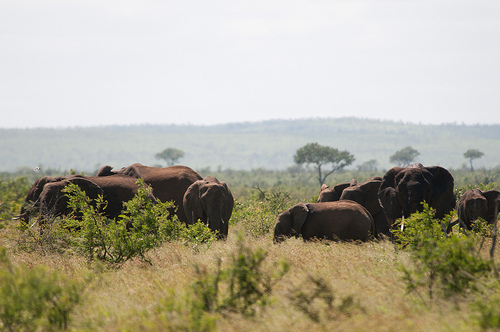Please provide a short description for this region: [0.45, 0.4, 0.56, 0.47]. This region depicts a distant mountain amidst a largely flat and grassy savannah landscape, giving a serene feel to the scene. 